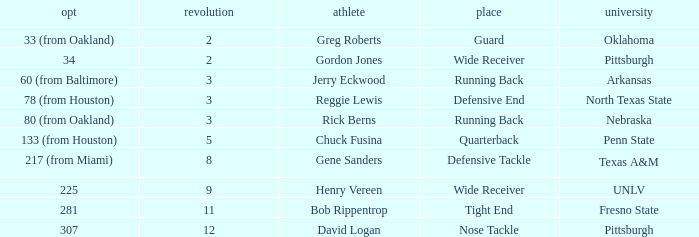What round was the nose tackle drafted? 12.0. 